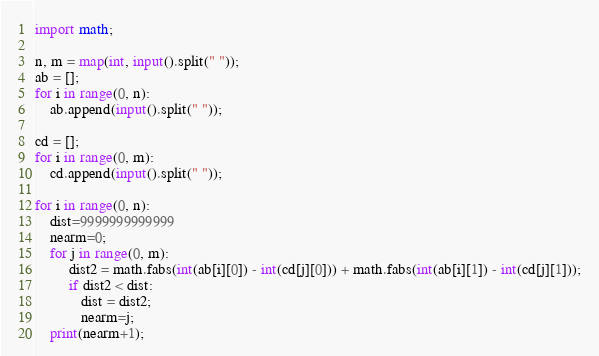Convert code to text. <code><loc_0><loc_0><loc_500><loc_500><_Python_>import math;

n, m = map(int, input().split(" "));
ab = [];
for i in range(0, n):
    ab.append(input().split(" "));

cd = [];
for i in range(0, m):
    cd.append(input().split(" "));

for i in range(0, n):
    dist=9999999999999
    nearm=0;
    for j in range(0, m):
         dist2 = math.fabs(int(ab[i][0]) - int(cd[j][0])) + math.fabs(int(ab[i][1]) - int(cd[j][1]));
         if dist2 < dist:
            dist = dist2;
            nearm=j;
    print(nearm+1);
</code> 